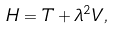Convert formula to latex. <formula><loc_0><loc_0><loc_500><loc_500>H = T + \lambda ^ { 2 } V ,</formula> 